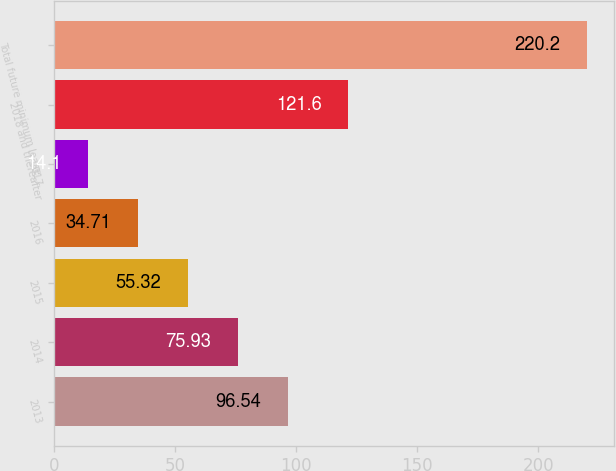Convert chart. <chart><loc_0><loc_0><loc_500><loc_500><bar_chart><fcel>2013<fcel>2014<fcel>2015<fcel>2016<fcel>2017<fcel>2018 and thereafter<fcel>Total future minimum lease<nl><fcel>96.54<fcel>75.93<fcel>55.32<fcel>34.71<fcel>14.1<fcel>121.6<fcel>220.2<nl></chart> 